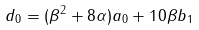<formula> <loc_0><loc_0><loc_500><loc_500>d _ { 0 } = ( \beta ^ { 2 } + 8 \alpha ) a _ { 0 } + 1 0 \beta b _ { 1 }</formula> 